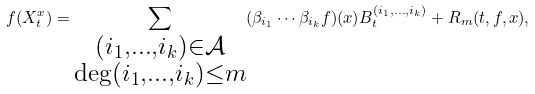Convert formula to latex. <formula><loc_0><loc_0><loc_500><loc_500>f ( X ^ { x } _ { t } ) = \sum _ { \substack { ( i _ { 1 } , \dots , i _ { k } ) \in \mathcal { A } \\ \deg ( i _ { 1 } , \dots , i _ { k } ) \leq m } } ( \beta _ { i _ { 1 } } \cdots \beta _ { i _ { k } } f ) ( x ) B ^ { ( i _ { 1 } , \dots , i _ { k } ) } _ { t } + R _ { m } ( t , f , x ) ,</formula> 